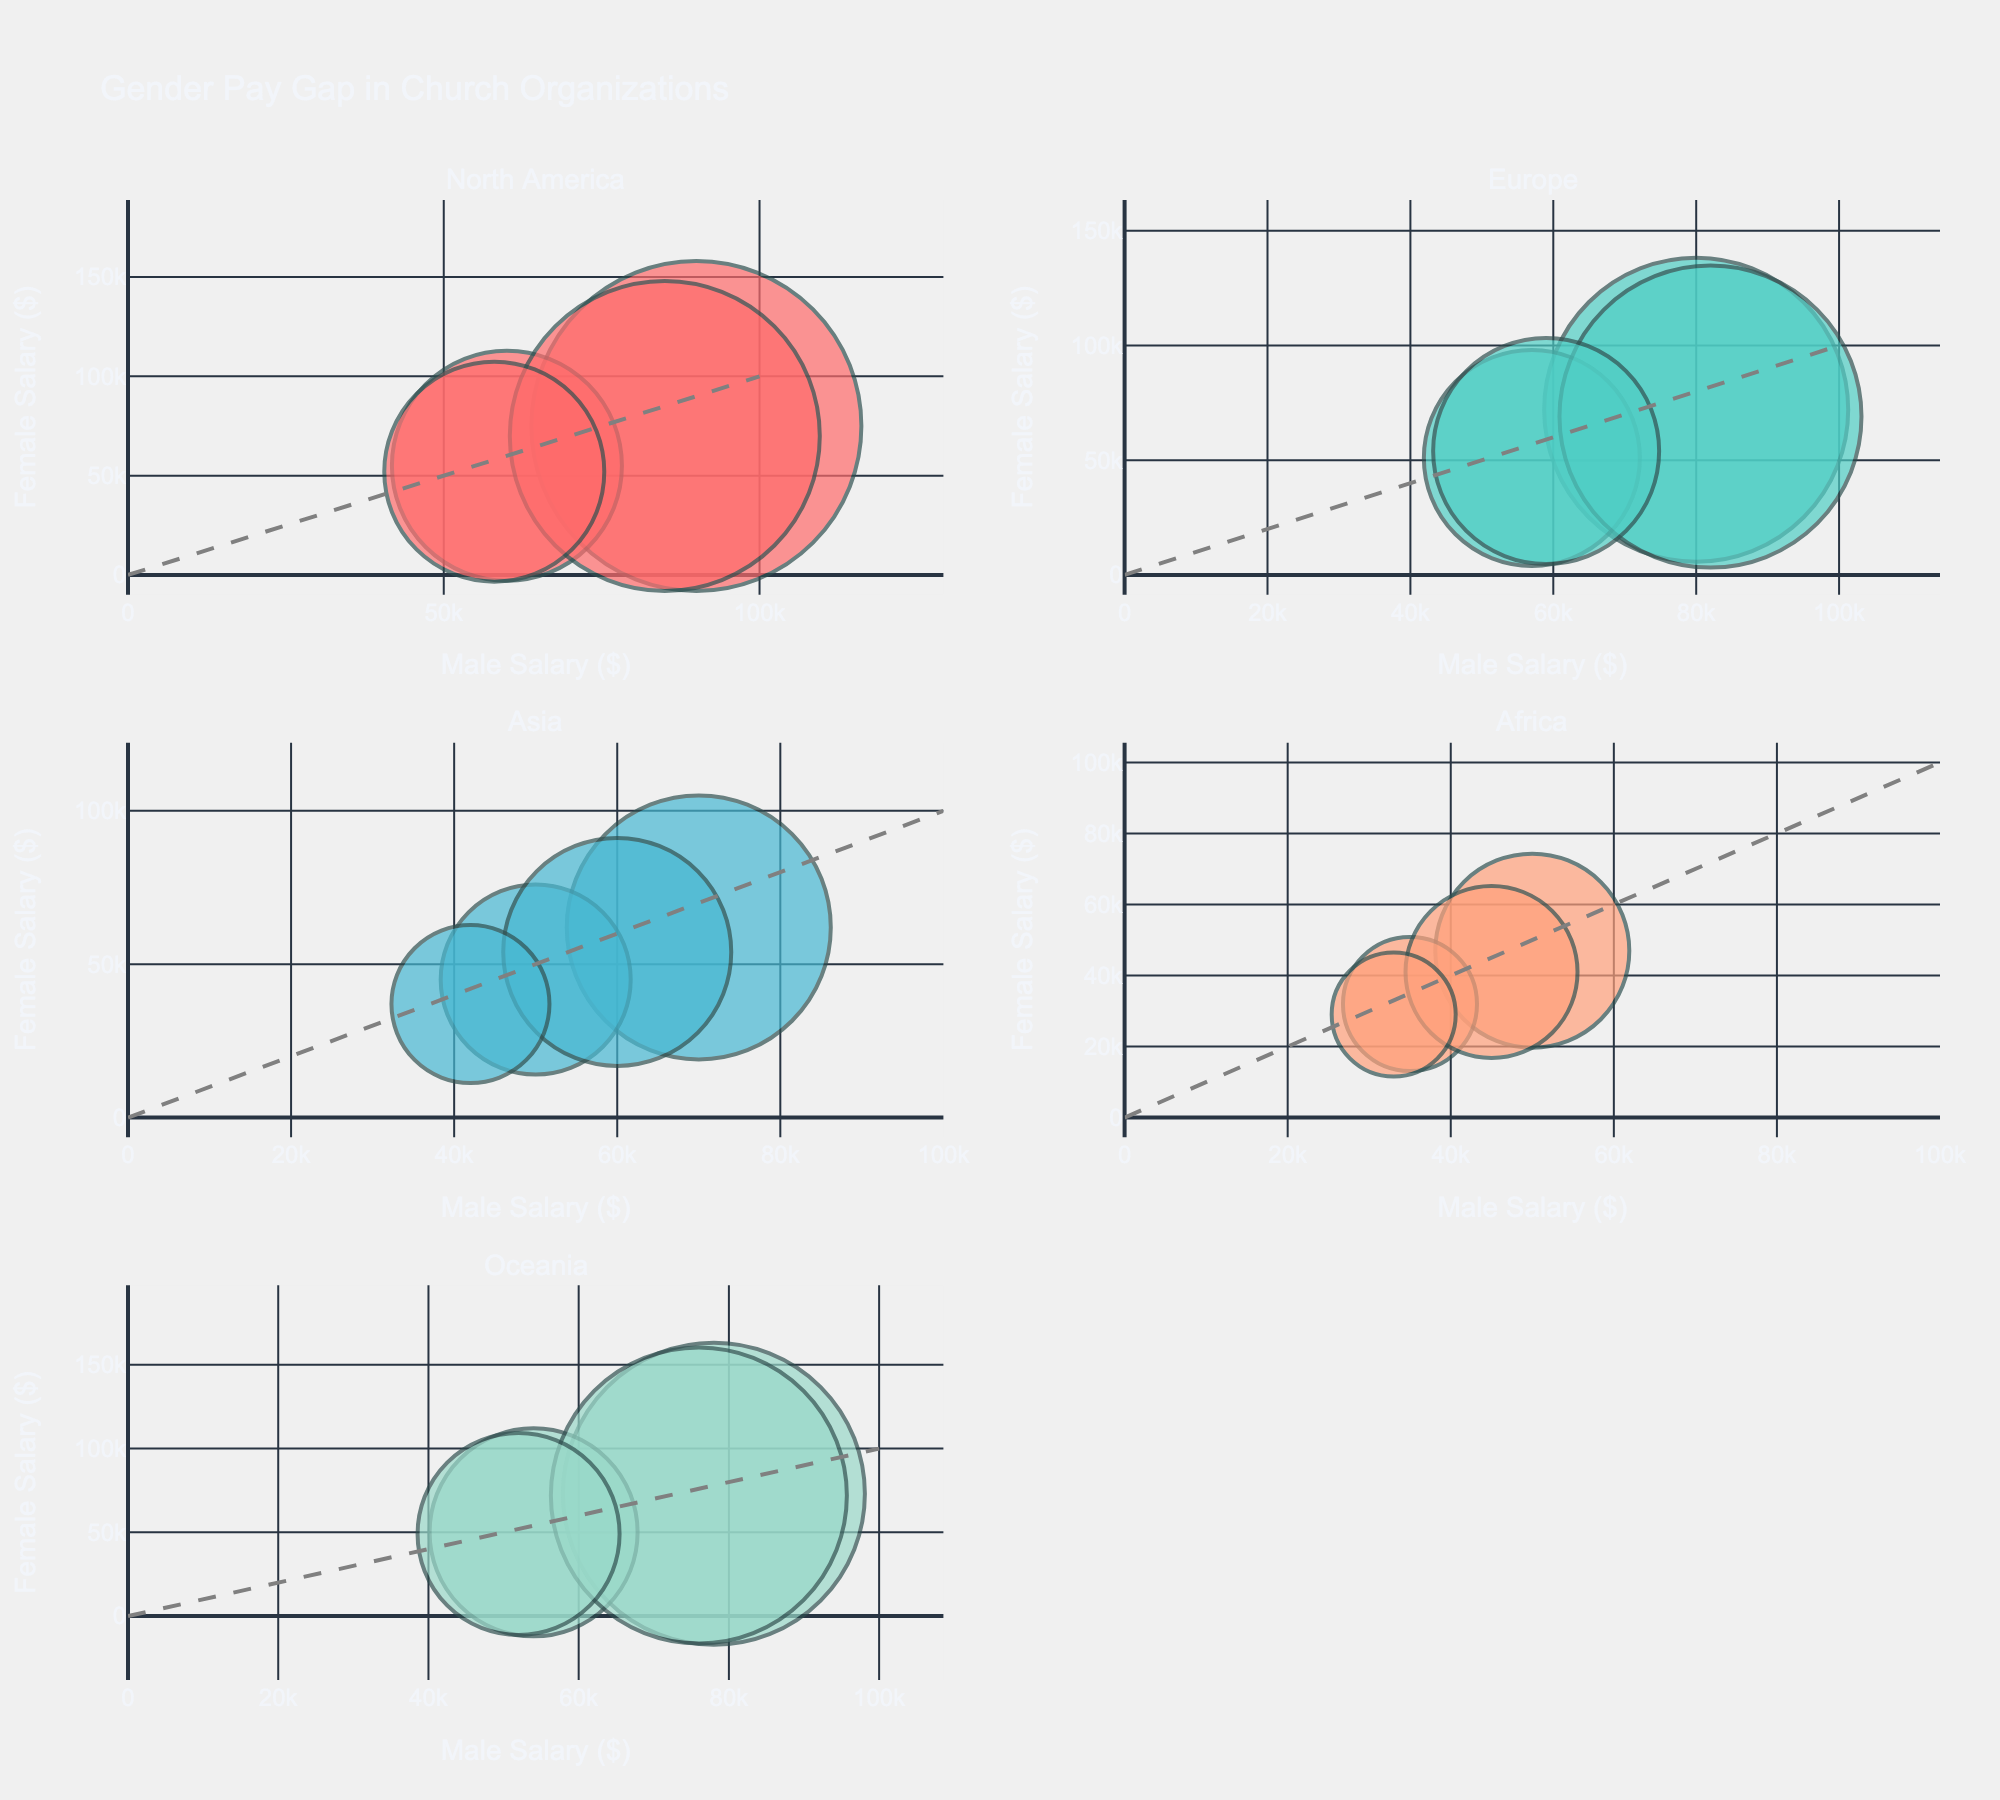What is the title of the plot? The title is located at the top center of the figure. It indicates the main subject of the visualized data.
Answer: Gender Pay Gap in Church Organizations How many geographic regions are represented in the figure? Each subplot represents a different geographic region, and the subplot titles indicate these regions. The figure shows six different subplots.
Answer: Six Which geographic region shows the largest pay gap between male and female Senior Pastors? By comparing the differences between the bubbles for Senior Pastors across subplots, the largest pay gap is observed in North America (United States) where the male salary is $90,000 and the female salary is $75,000, making a gap of $15,000.
Answer: North America (United States) In which country do Associate Pastors have the smallest pay gap? The pay gaps can be identified by looking at the bubbles of Associate Pastors in each country. The smallest pay gap is seen in the United Kingdom, with male salaries at $57,000 and female salaries at $51,000, making a gap of $6,000.
Answer: United Kingdom Which hierarchical position generally has larger bubbles, and why might this be the case? Larger bubbles represent higher average salaries for both genders combined. Senior Pastors generally have larger bubbles since their combined average salaries are higher than those of Associate Pastors.
Answer: Senior Pastors Is there a region where the salary for female Senior Pastors is higher than $70,000? By inspecting the y-axis values, which represent female salaries, Europe (United Kingdom and Germany) and Oceania (Australia and New Zealand) both show female Senior Pastor salaries above $70,000.
Answer: Europe and Oceania Compare the salaries of Senior Pastors and Associate Pastors in Asia. Which positions show larger pay gaps? The pay gaps are defined by the difference in salaries between genders for each position. For both South Korea and the Philippines, Senior Pastor positions show larger gaps ($80,000-$62,000=$18,000 in South Korea and $60,000-$54,000=$6,000 in Philippines) compared to Associate Pastor positions ($50,000-$45,000=$5,000 in South Korea and $42,000-$37,000=$5,000 in Philippines).
Answer: Senior Pastors in Asia Identify any outlier bubbles with significant deviations from the diagonal reference line (representing equal pay). By observing which bubbles deviate most from the diagonal line, we see that the United States Senior Pastor bubble is the most prominent outlier, indicating a significant pay gap.
Answer: United States (Senior Pastor) What is the average pay gap for Senior Pastors in Europe? Pay gap in the United Kingdom: $8,000 ($80,000 - $72,000). Pay gap in Germany: $13,000 ($82,000 - $69,000). Average = ($8,000 + $13,000) / 2 = $10,500.
Answer: $10,500 